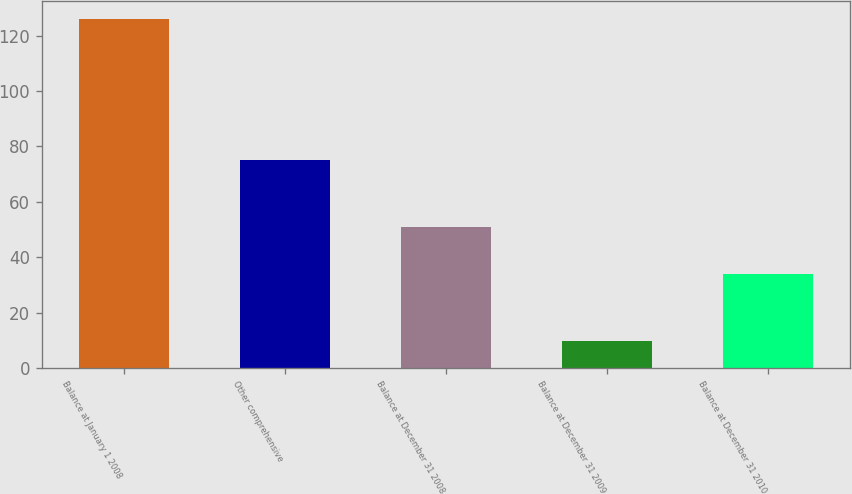Convert chart. <chart><loc_0><loc_0><loc_500><loc_500><bar_chart><fcel>Balance at January 1 2008<fcel>Other comprehensive<fcel>Balance at December 31 2008<fcel>Balance at December 31 2009<fcel>Balance at December 31 2010<nl><fcel>126<fcel>75<fcel>51<fcel>10<fcel>34<nl></chart> 